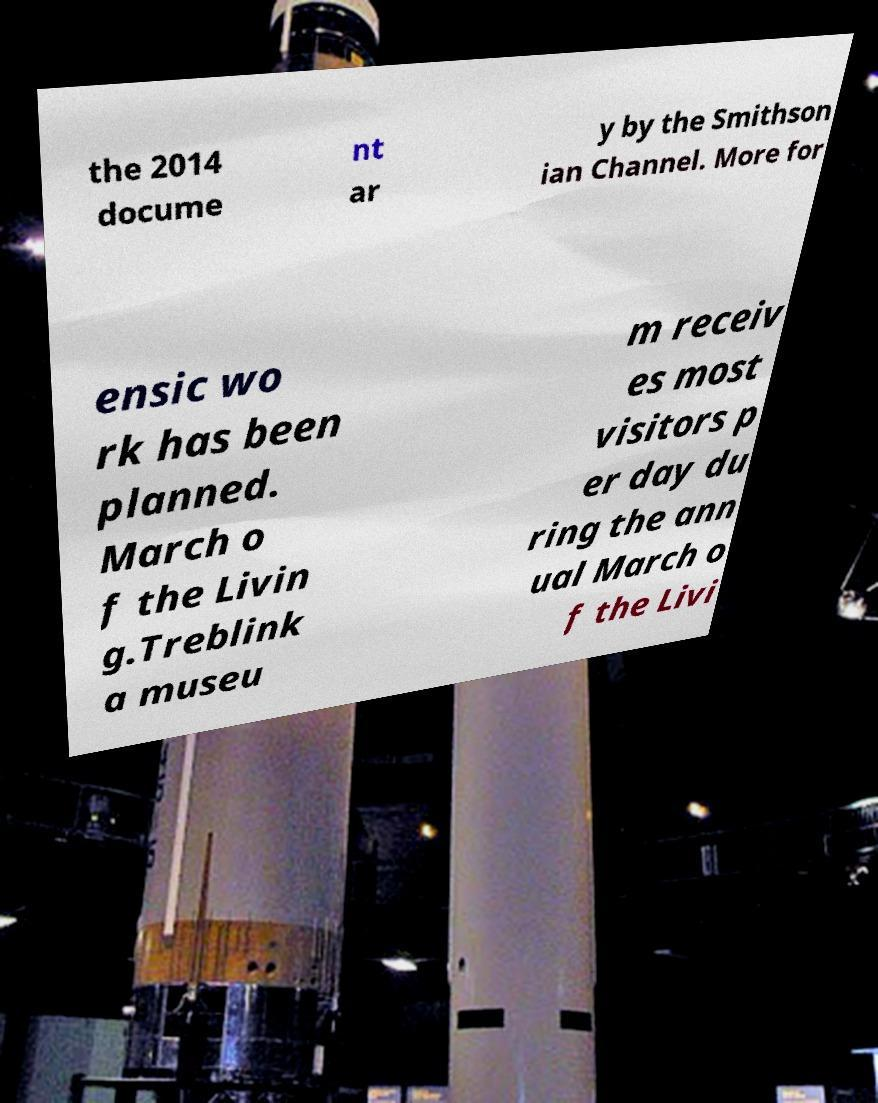Can you read and provide the text displayed in the image?This photo seems to have some interesting text. Can you extract and type it out for me? the 2014 docume nt ar y by the Smithson ian Channel. More for ensic wo rk has been planned. March o f the Livin g.Treblink a museu m receiv es most visitors p er day du ring the ann ual March o f the Livi 